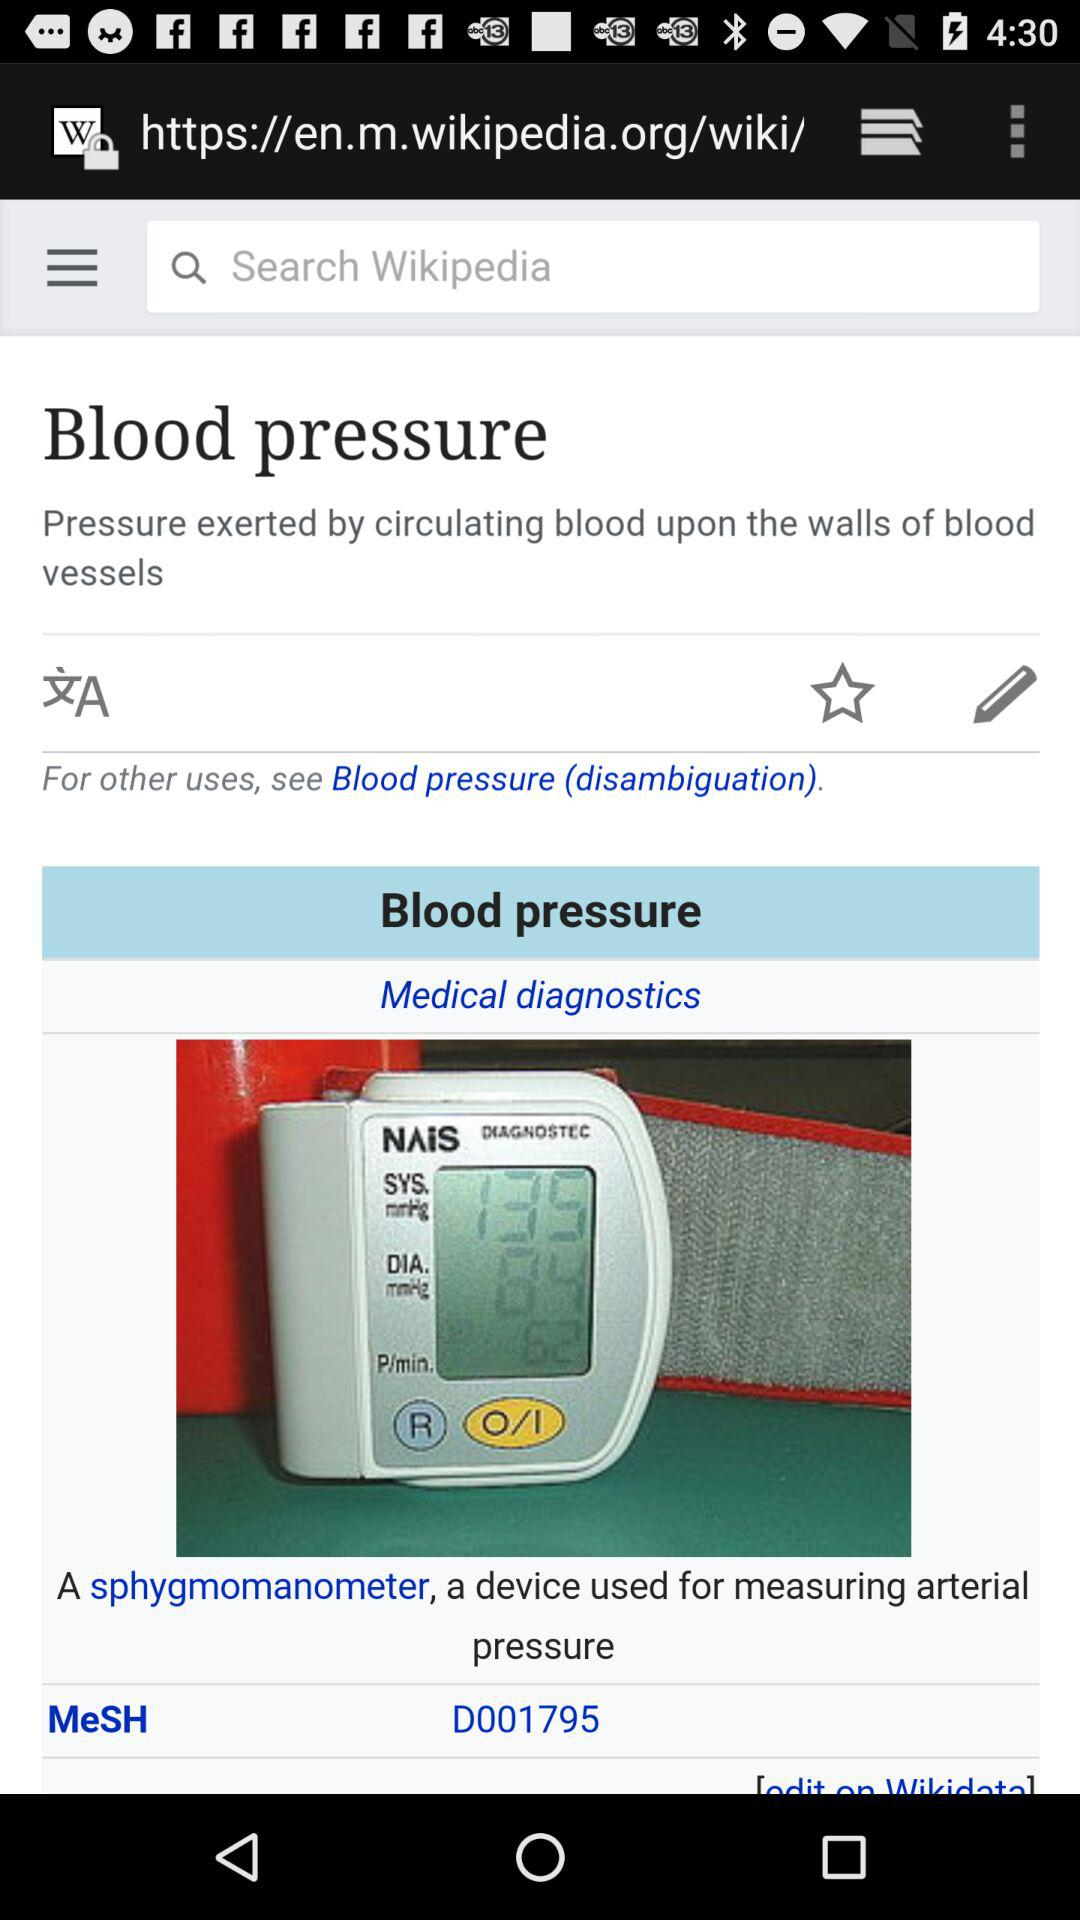What is the diastolic pressure? The diastolic pressure is 84. 